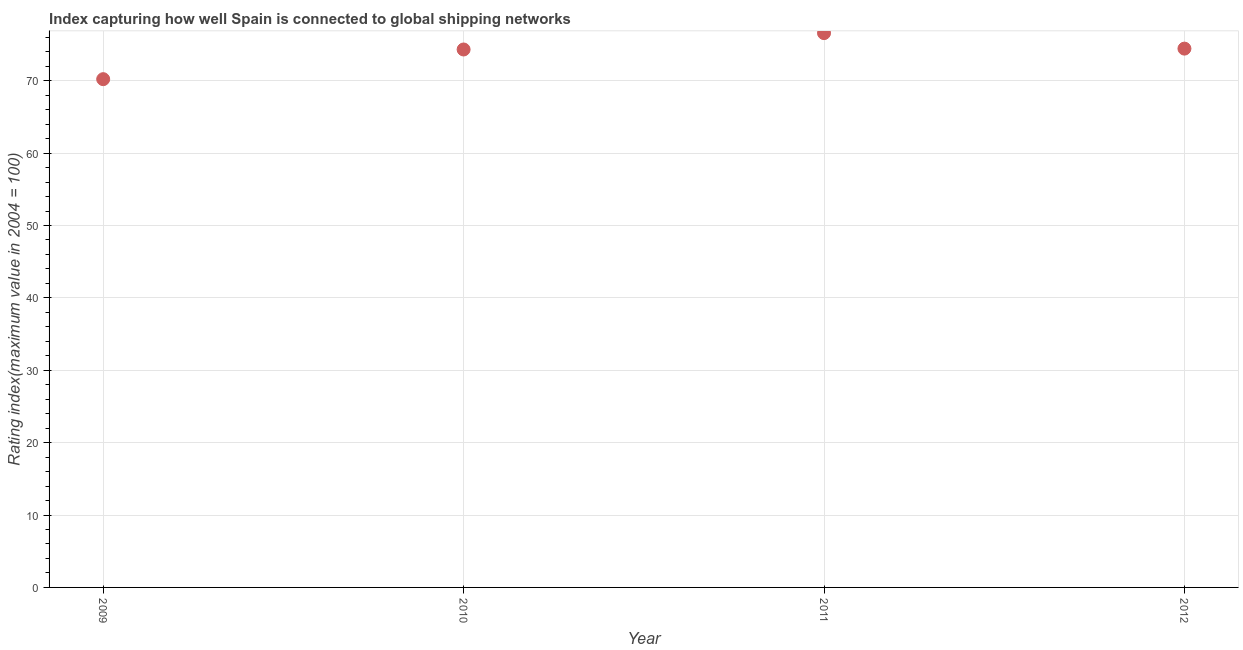What is the liner shipping connectivity index in 2009?
Your answer should be compact. 70.22. Across all years, what is the maximum liner shipping connectivity index?
Keep it short and to the point. 76.58. Across all years, what is the minimum liner shipping connectivity index?
Make the answer very short. 70.22. In which year was the liner shipping connectivity index maximum?
Your response must be concise. 2011. In which year was the liner shipping connectivity index minimum?
Keep it short and to the point. 2009. What is the sum of the liner shipping connectivity index?
Make the answer very short. 295.56. What is the difference between the liner shipping connectivity index in 2011 and 2012?
Your answer should be very brief. 2.14. What is the average liner shipping connectivity index per year?
Offer a terse response. 73.89. What is the median liner shipping connectivity index?
Make the answer very short. 74.38. What is the ratio of the liner shipping connectivity index in 2009 to that in 2011?
Keep it short and to the point. 0.92. Is the difference between the liner shipping connectivity index in 2009 and 2011 greater than the difference between any two years?
Make the answer very short. Yes. What is the difference between the highest and the second highest liner shipping connectivity index?
Provide a succinct answer. 2.14. What is the difference between the highest and the lowest liner shipping connectivity index?
Give a very brief answer. 6.36. In how many years, is the liner shipping connectivity index greater than the average liner shipping connectivity index taken over all years?
Keep it short and to the point. 3. How many years are there in the graph?
Ensure brevity in your answer.  4. What is the difference between two consecutive major ticks on the Y-axis?
Offer a very short reply. 10. Does the graph contain any zero values?
Give a very brief answer. No. What is the title of the graph?
Your answer should be compact. Index capturing how well Spain is connected to global shipping networks. What is the label or title of the Y-axis?
Your answer should be compact. Rating index(maximum value in 2004 = 100). What is the Rating index(maximum value in 2004 = 100) in 2009?
Provide a succinct answer. 70.22. What is the Rating index(maximum value in 2004 = 100) in 2010?
Give a very brief answer. 74.32. What is the Rating index(maximum value in 2004 = 100) in 2011?
Provide a short and direct response. 76.58. What is the Rating index(maximum value in 2004 = 100) in 2012?
Provide a short and direct response. 74.44. What is the difference between the Rating index(maximum value in 2004 = 100) in 2009 and 2010?
Ensure brevity in your answer.  -4.1. What is the difference between the Rating index(maximum value in 2004 = 100) in 2009 and 2011?
Keep it short and to the point. -6.36. What is the difference between the Rating index(maximum value in 2004 = 100) in 2009 and 2012?
Your answer should be compact. -4.22. What is the difference between the Rating index(maximum value in 2004 = 100) in 2010 and 2011?
Provide a short and direct response. -2.26. What is the difference between the Rating index(maximum value in 2004 = 100) in 2010 and 2012?
Give a very brief answer. -0.12. What is the difference between the Rating index(maximum value in 2004 = 100) in 2011 and 2012?
Your response must be concise. 2.14. What is the ratio of the Rating index(maximum value in 2004 = 100) in 2009 to that in 2010?
Your answer should be very brief. 0.94. What is the ratio of the Rating index(maximum value in 2004 = 100) in 2009 to that in 2011?
Offer a very short reply. 0.92. What is the ratio of the Rating index(maximum value in 2004 = 100) in 2009 to that in 2012?
Offer a terse response. 0.94. What is the ratio of the Rating index(maximum value in 2004 = 100) in 2010 to that in 2012?
Provide a short and direct response. 1. 